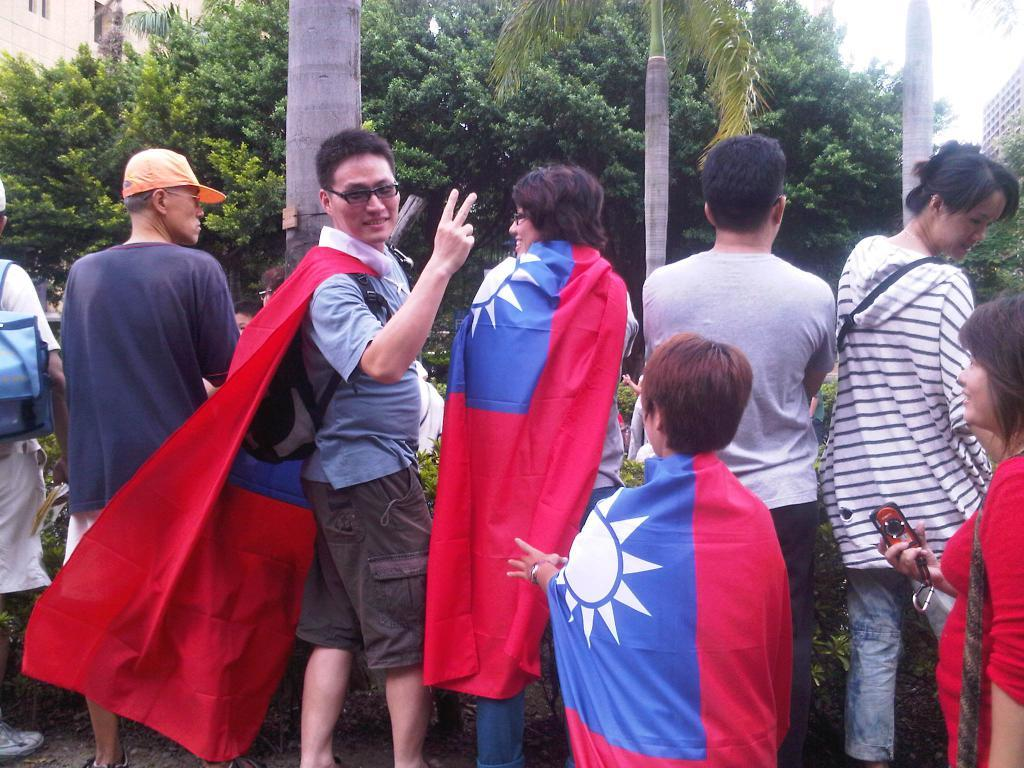What can be observed about the people in the image? There are people standing in the image. What are some of the people holding in their hands? Some people are holding bags and objects in their hands. What type of natural elements are present in the image? There are plants and trees in the image. What type of man-made structures can be seen in the image? There are buildings in the image. Where is the cave located in the image? There is no cave present in the image. How many women are visible in the image? The provided facts do not specify the gender of the people in the image, so it cannot be determined how many women are visible. 